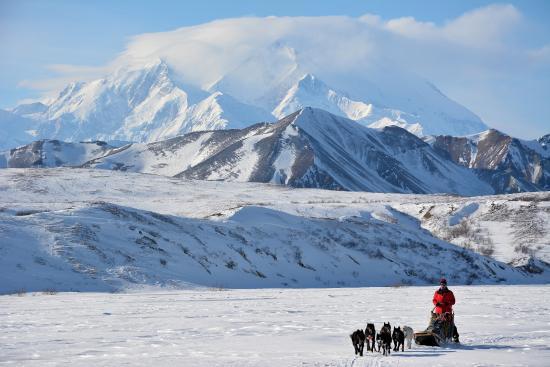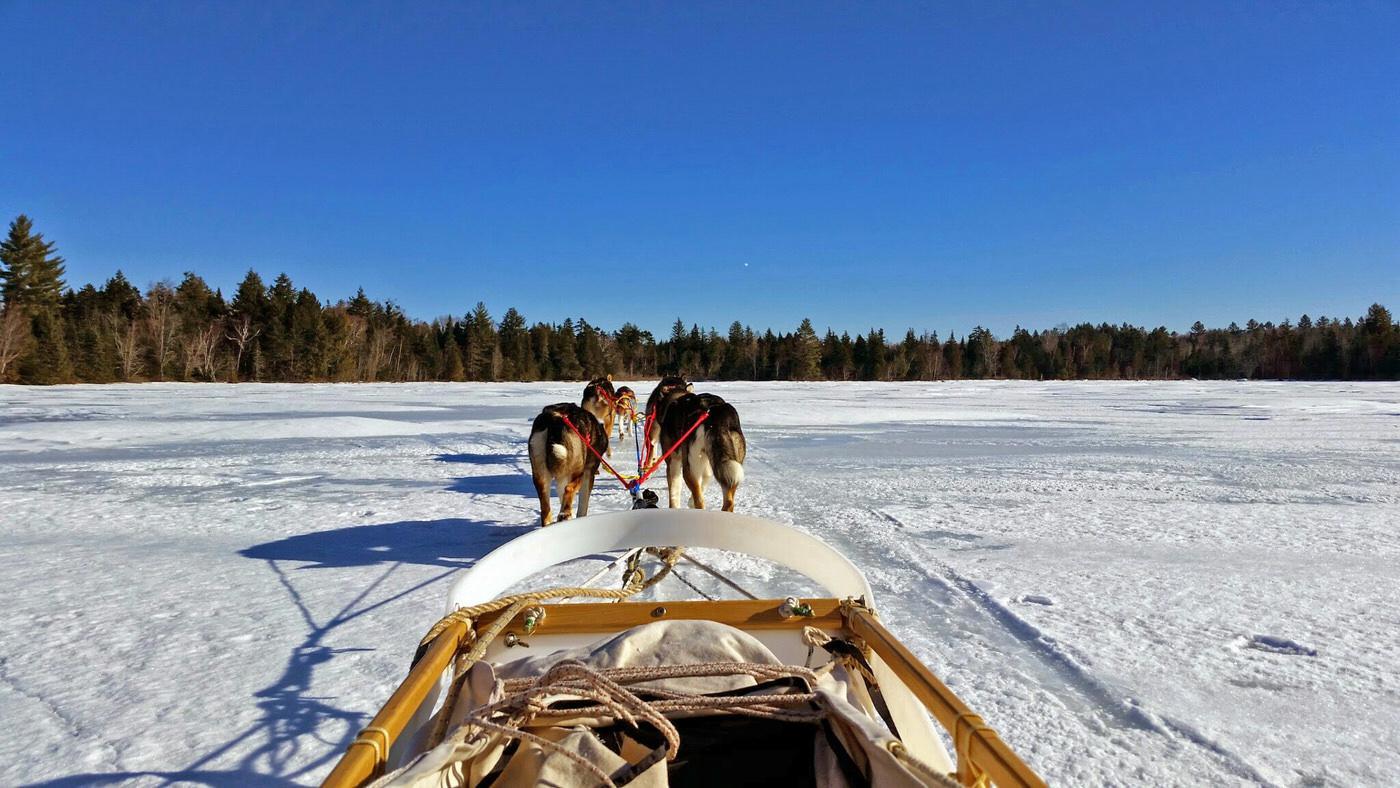The first image is the image on the left, the second image is the image on the right. Considering the images on both sides, is "One image shows a sled driver standing on the right, behind a red sled that's in profile, with a team of leftward-aimed dogs hitched to it." valid? Answer yes or no. No. The first image is the image on the left, the second image is the image on the right. For the images shown, is this caption "There is exactly one sled driver visible." true? Answer yes or no. Yes. 